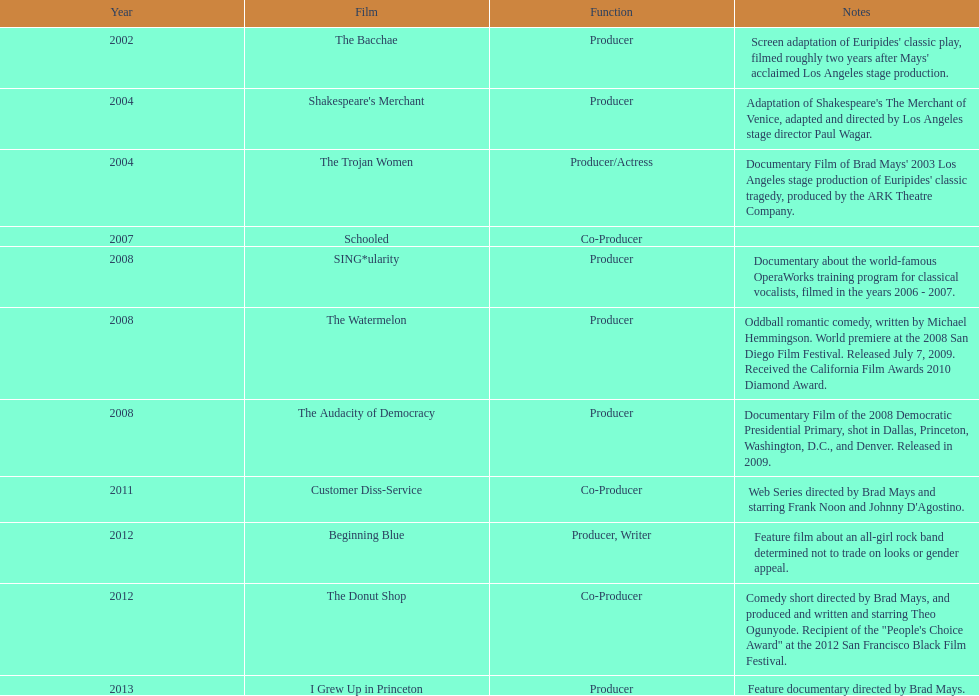Prior to the audacity of democracy, what was the film? The Watermelon. 